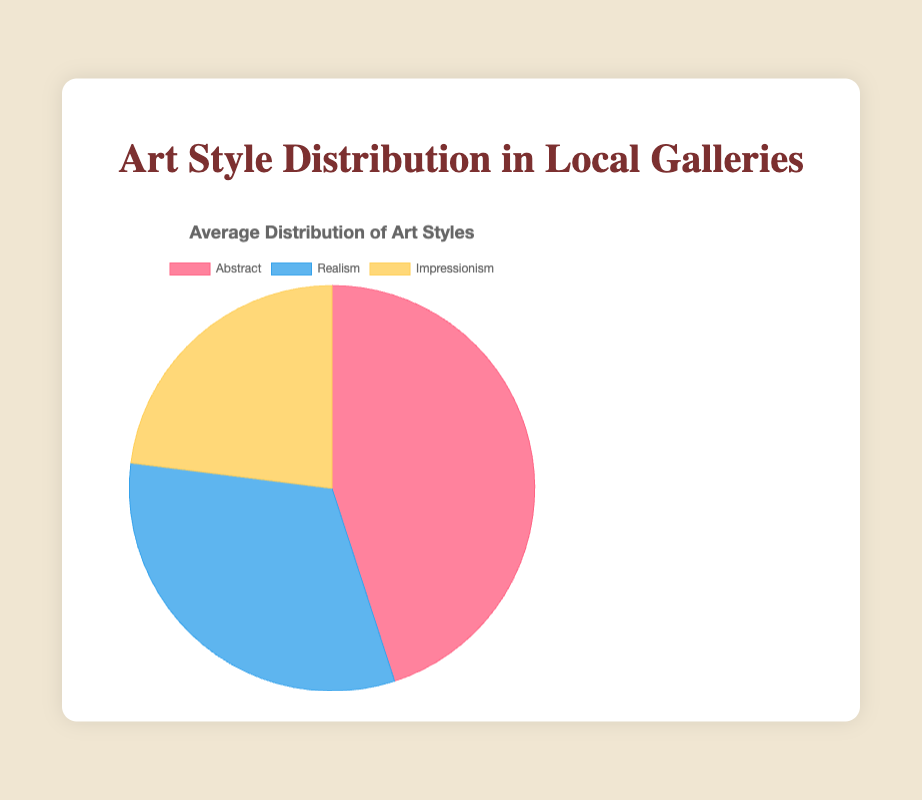What is the most preferred art style among the local galleries? The figure shows that Abstract has the largest portion of the pie chart and hence is the most preferred art style among the local galleries.
Answer: Abstract Which art style has the smallest share of the pie chart? By observing the pie chart segments, Impressionism has the smallest share.
Answer: Impressionism What is the average percentage distribution of Impressionism across the galleries? Summing the Impressionism percentages (20, 15, 30, 20, 30) gives 115. The average would be 115 divided by the number of galleries, which is 5. So, 115/5 = 23%.
Answer: 23% Compare the distribution of Realism and Impressionism. Which one is preferred? By comparing the segments, Realism has a larger share than Impressionism.
Answer: Realism What is the combined percentage of Abstract and Realism? Adding the percentages for Abstract (45) and Realism (32) gives 45 + 32 = 77%.
Answer: 77% Which gallery has the highest percentage of Abstract art? According to the data, the Modern Arts Exhibit has the highest percentage of Abstract art (60%).
Answer: Modern Arts Exhibit Is the percentage of Realism higher than Abstract in any of the galleries? By reviewing the data for each gallery, Renaissance Installations has a higher percentage of Realism (50%) compared to Abstract (30%).
Answer: Yes, in Renaissance Installations What is the difference in percentages between Realism and Impressionism? The difference can be calculated by subtracting the percentage of Impressionism (23%) from Realism (32%). So, 32 - 23 = 9%.
Answer: 9% Which art style has the second largest share in the pie chart? Examining the pie chart, Realism has the second largest share after Abstract.
Answer: Realism 